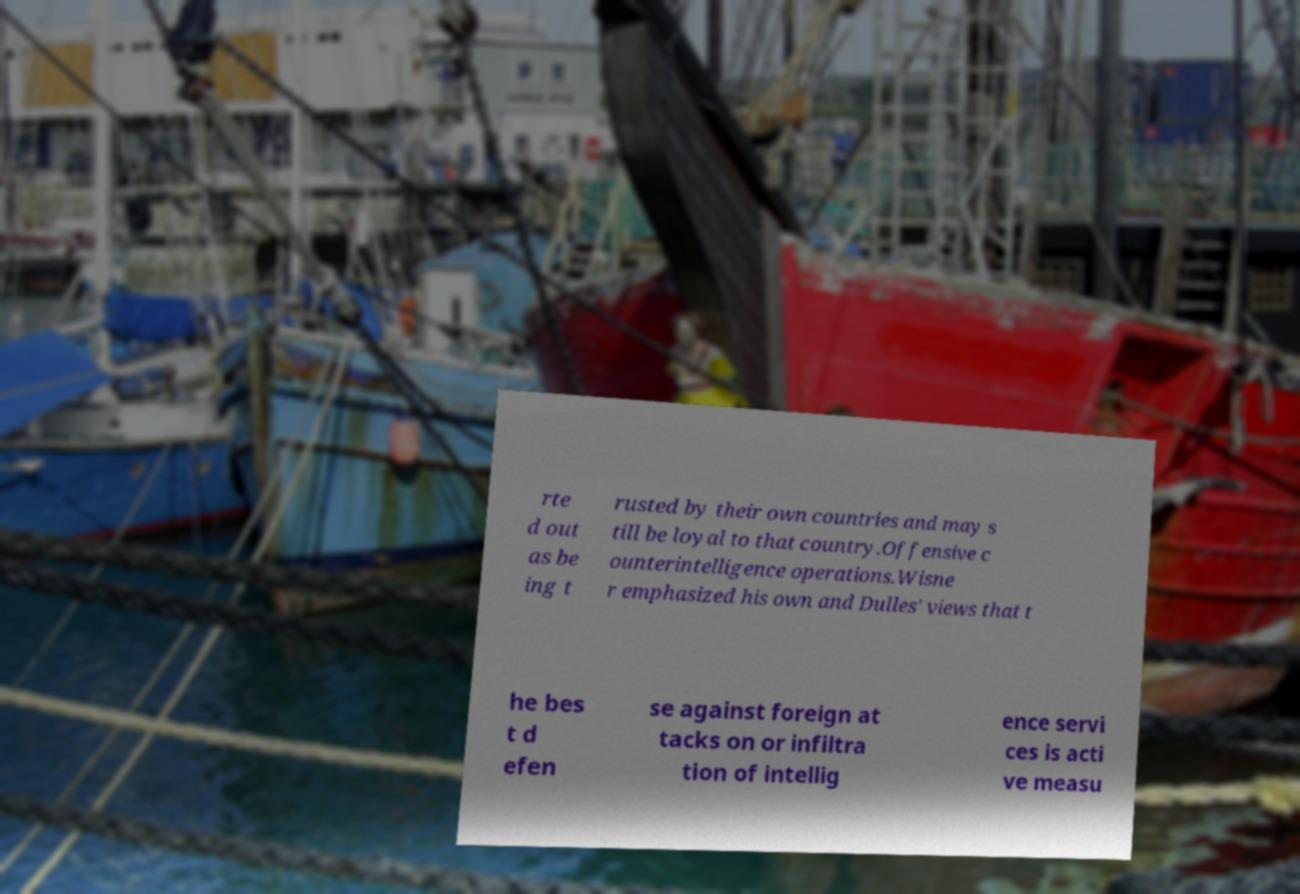I need the written content from this picture converted into text. Can you do that? rte d out as be ing t rusted by their own countries and may s till be loyal to that country.Offensive c ounterintelligence operations.Wisne r emphasized his own and Dulles' views that t he bes t d efen se against foreign at tacks on or infiltra tion of intellig ence servi ces is acti ve measu 